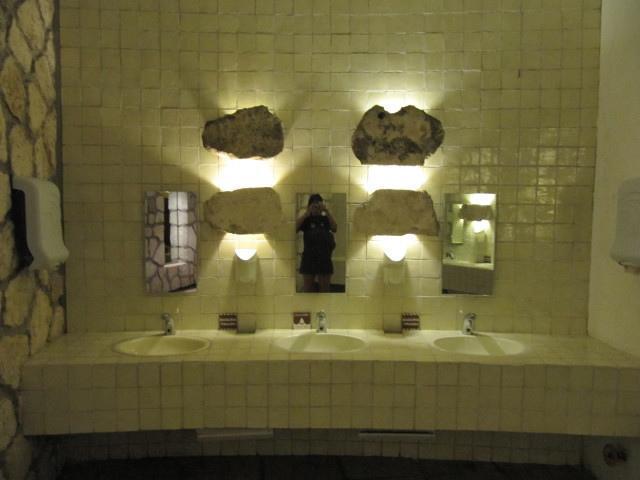How many sinks are in the bathroom?
Give a very brief answer. 3. How many people are there?
Give a very brief answer. 1. 